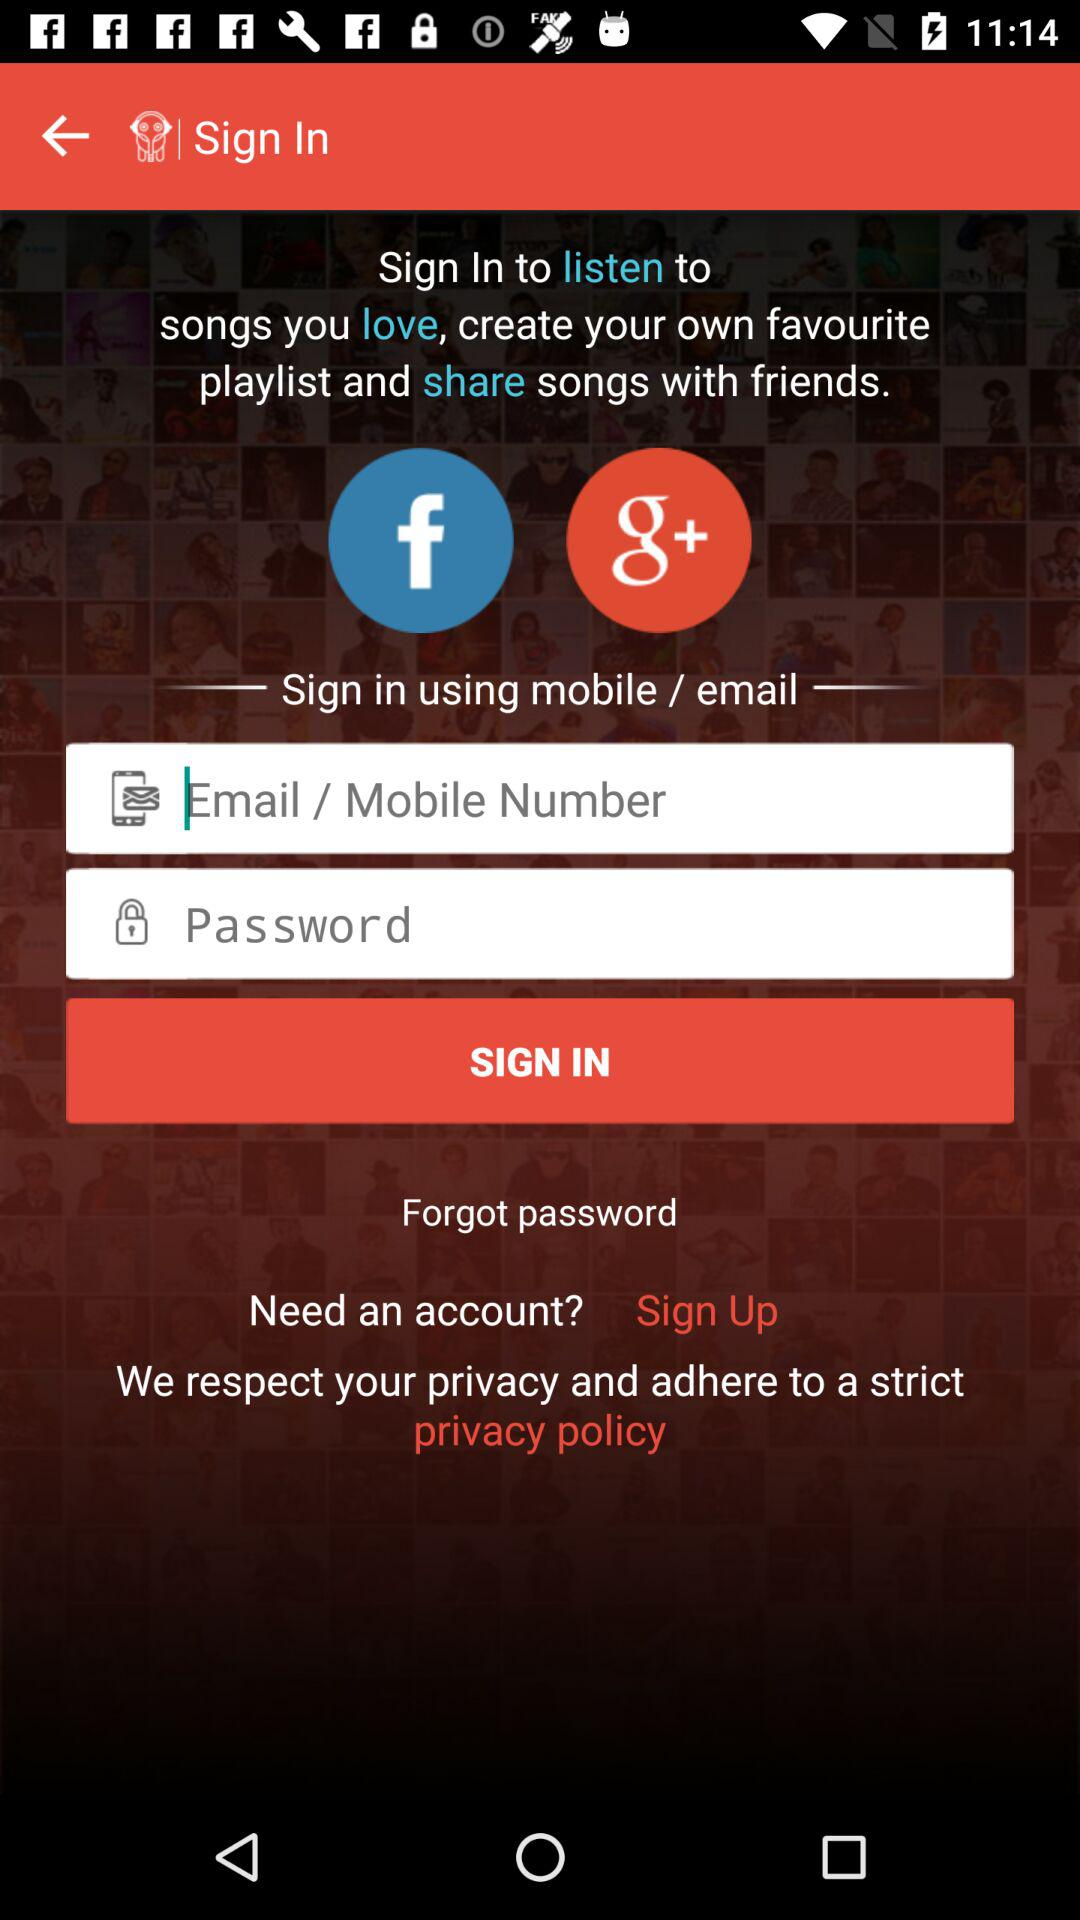How many inputs are there for signing in?
Answer the question using a single word or phrase. 2 